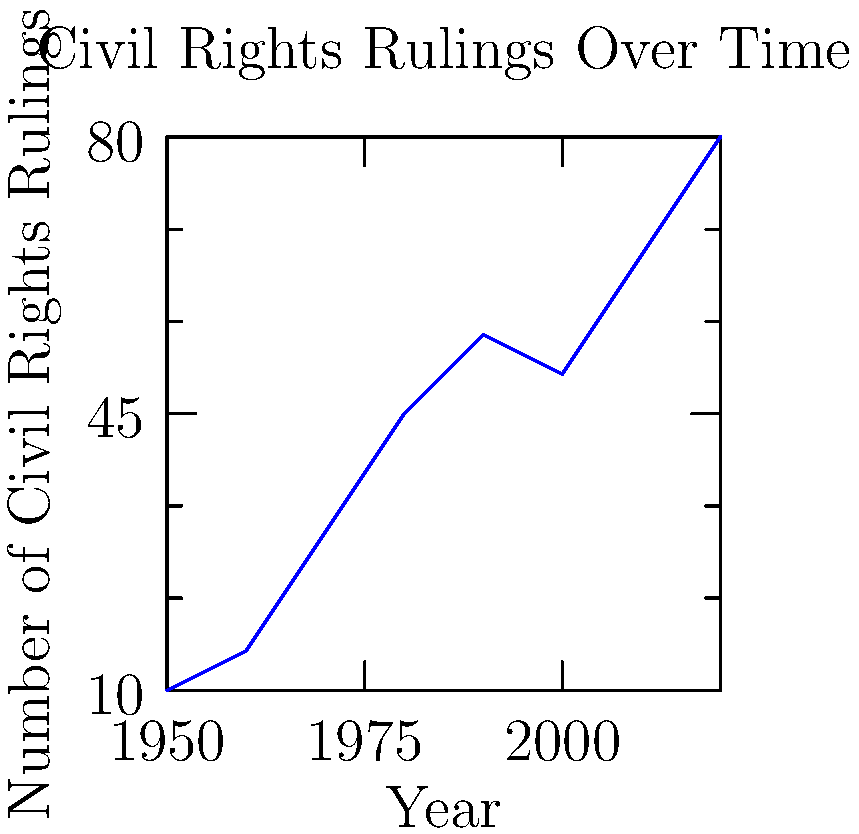Based on the line chart showing the trend of civil rights rulings over time, during which decade did the number of civil rights rulings experience the most significant increase? To determine the decade with the most significant increase in civil rights rulings, we need to analyze the slope of the line between each consecutive decade:

1. 1950-1960: Increase from 10 to 15 (change of 5)
2. 1960-1970: Increase from 15 to 30 (change of 15)
3. 1970-1980: Increase from 30 to 45 (change of 15)
4. 1980-1990: Increase from 45 to 55 (change of 10)
5. 1990-2000: Decrease from 55 to 50 (change of -5)
6. 2000-2010: Increase from 50 to 65 (change of 15)
7. 2010-2020: Increase from 65 to 80 (change of 15)

The most significant increase occurred between 1960 and 1970, with a change of 15 rulings. This increase is matched in later decades, but it represents a larger percentage increase given the lower starting point in 1960.
Answer: 1960-1970 